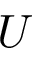Convert formula to latex. <formula><loc_0><loc_0><loc_500><loc_500>U</formula> 